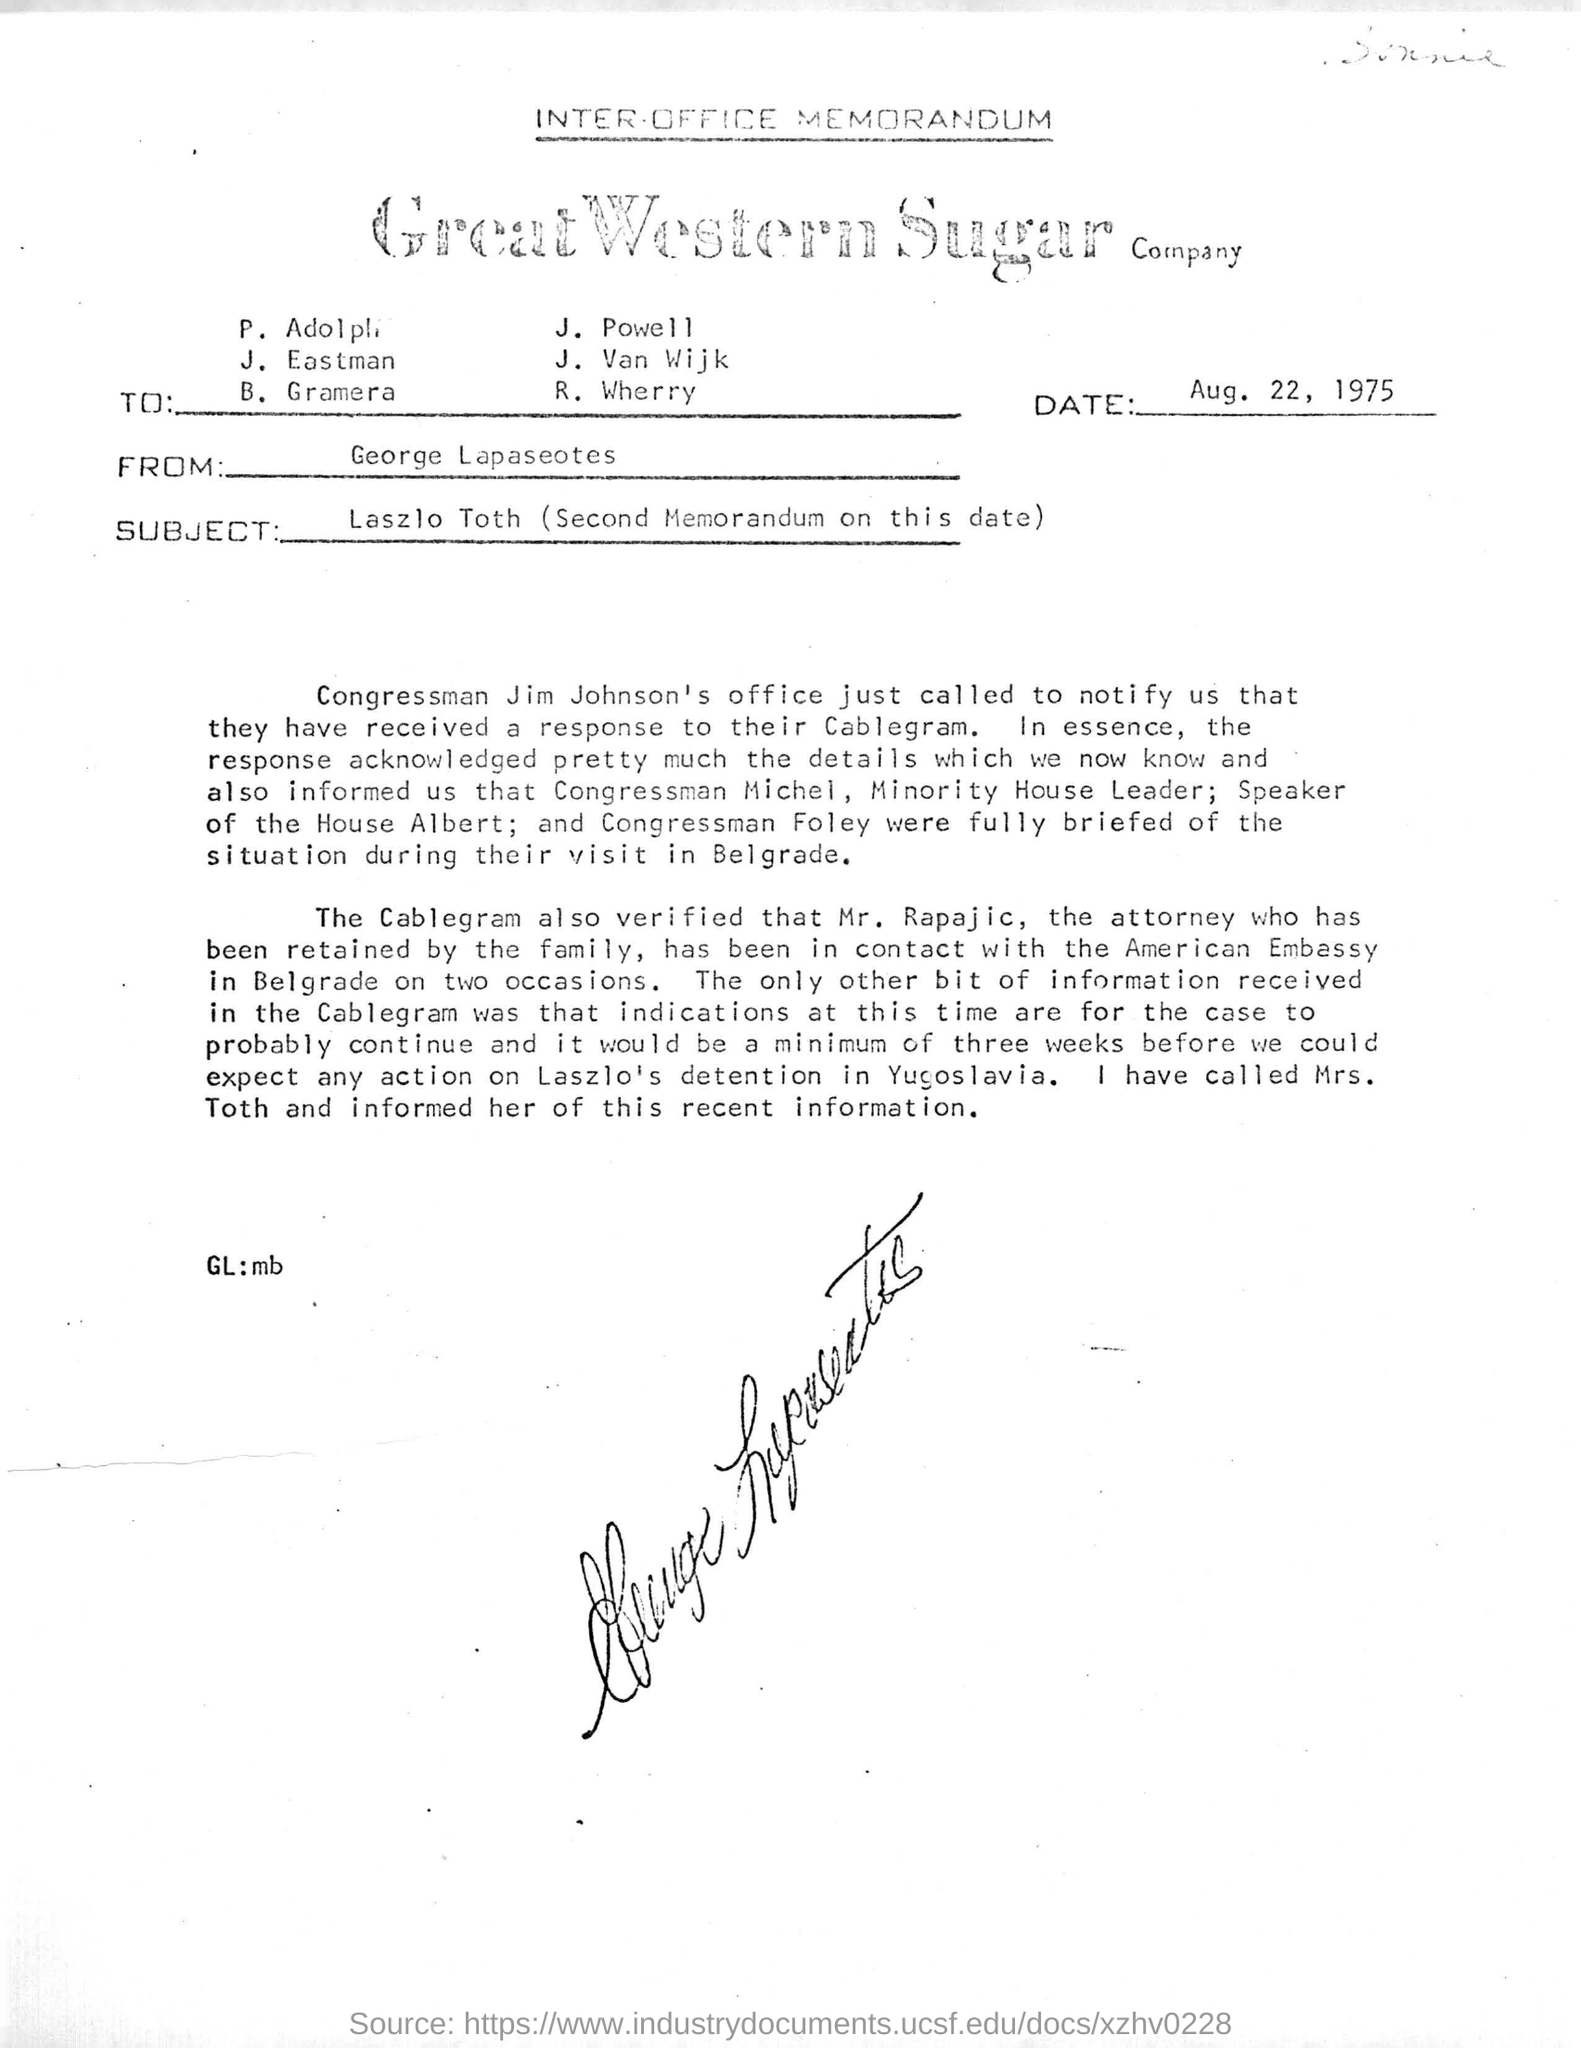Indicate a few pertinent items in this graphic. The date of this document is August 22, 1975. The subject of this memorandum is Laszlo Toth, and a second memorandum was sent on this date. The minority leader in the House of Representatives is Congressman Michel, who is a member of the Democratic Party. The Speaker of the House is Albert. The sender of this letter is George Lapaseotes. 